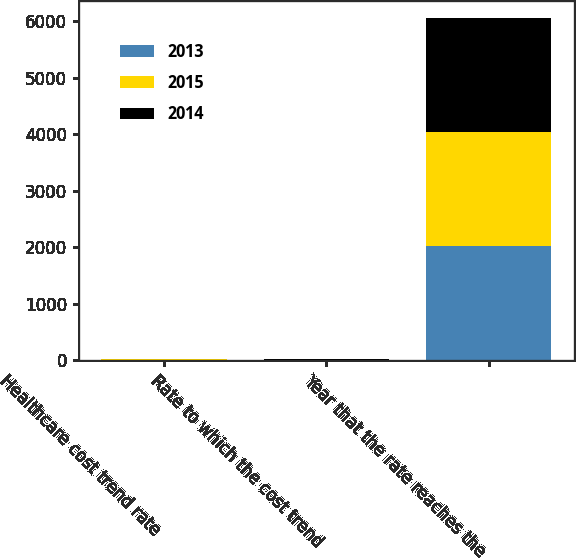<chart> <loc_0><loc_0><loc_500><loc_500><stacked_bar_chart><ecel><fcel>Healthcare cost trend rate<fcel>Rate to which the cost trend<fcel>Year that the rate reaches the<nl><fcel>2013<fcel>5.5<fcel>4.5<fcel>2018<nl><fcel>2015<fcel>6<fcel>4.5<fcel>2018<nl><fcel>2014<fcel>6.4<fcel>4.5<fcel>2019<nl></chart> 